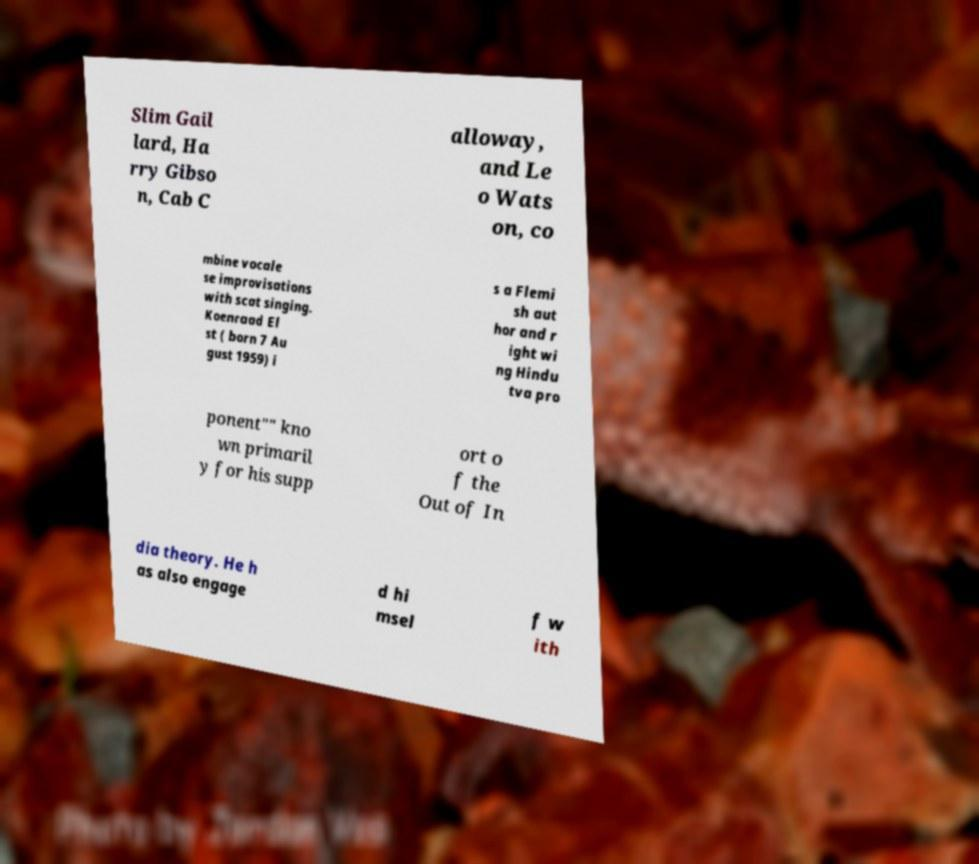Could you assist in decoding the text presented in this image and type it out clearly? Slim Gail lard, Ha rry Gibso n, Cab C alloway, and Le o Wats on, co mbine vocale se improvisations with scat singing. Koenraad El st ( born 7 Au gust 1959) i s a Flemi sh aut hor and r ight wi ng Hindu tva pro ponent"" kno wn primaril y for his supp ort o f the Out of In dia theory. He h as also engage d hi msel f w ith 